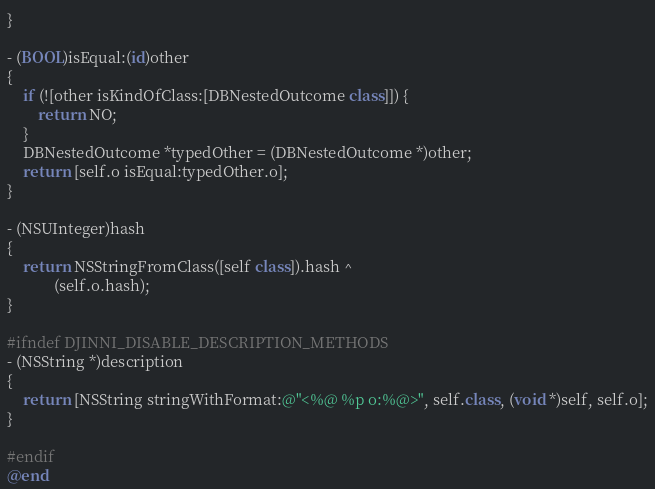Convert code to text. <code><loc_0><loc_0><loc_500><loc_500><_ObjectiveC_>}

- (BOOL)isEqual:(id)other
{
    if (![other isKindOfClass:[DBNestedOutcome class]]) {
        return NO;
    }
    DBNestedOutcome *typedOther = (DBNestedOutcome *)other;
    return [self.o isEqual:typedOther.o];
}

- (NSUInteger)hash
{
    return NSStringFromClass([self class]).hash ^
            (self.o.hash);
}

#ifndef DJINNI_DISABLE_DESCRIPTION_METHODS
- (NSString *)description
{
    return [NSString stringWithFormat:@"<%@ %p o:%@>", self.class, (void *)self, self.o];
}

#endif
@end
</code> 